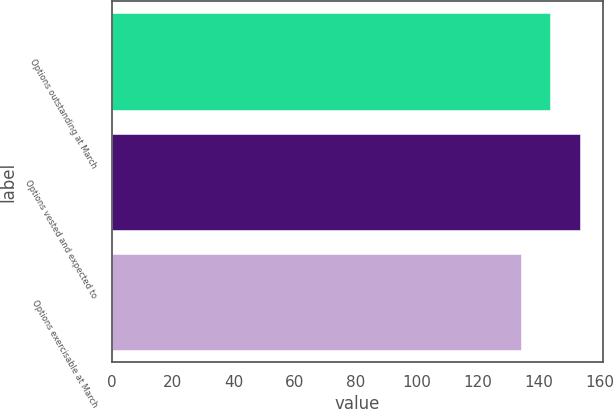<chart> <loc_0><loc_0><loc_500><loc_500><bar_chart><fcel>Options outstanding at March<fcel>Options vested and expected to<fcel>Options exercisable at March<nl><fcel>143.7<fcel>153.4<fcel>134<nl></chart> 